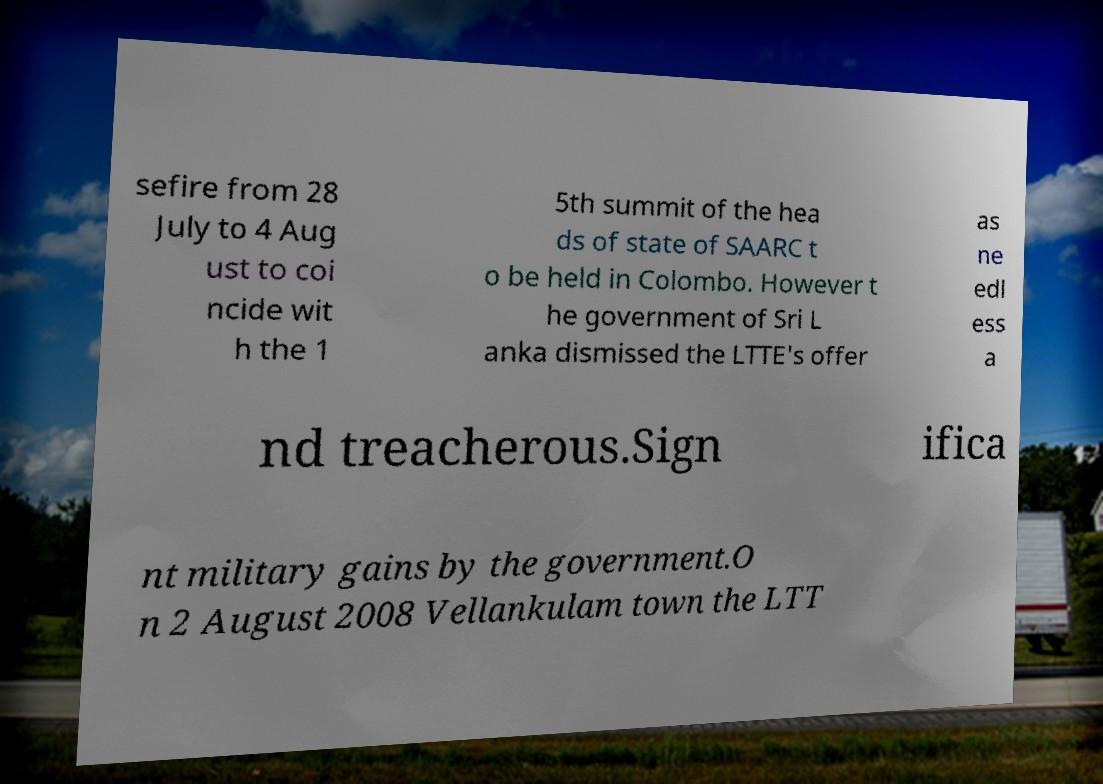What messages or text are displayed in this image? I need them in a readable, typed format. sefire from 28 July to 4 Aug ust to coi ncide wit h the 1 5th summit of the hea ds of state of SAARC t o be held in Colombo. However t he government of Sri L anka dismissed the LTTE's offer as ne edl ess a nd treacherous.Sign ifica nt military gains by the government.O n 2 August 2008 Vellankulam town the LTT 